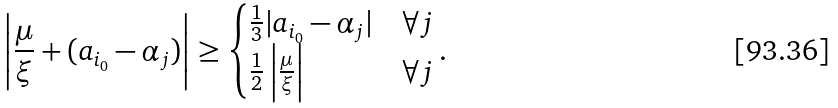<formula> <loc_0><loc_0><loc_500><loc_500>\left | \frac { \mu } { \xi } + ( a _ { i _ { 0 } } - \alpha _ { j } ) \right | \geq \begin{cases} \frac { 1 } { 3 } | a _ { i _ { 0 } } - \alpha _ { j } | & \forall j \\ \frac { 1 } { 2 } \left | \frac { \mu } { \xi } \right | & \forall j \end{cases} .</formula> 